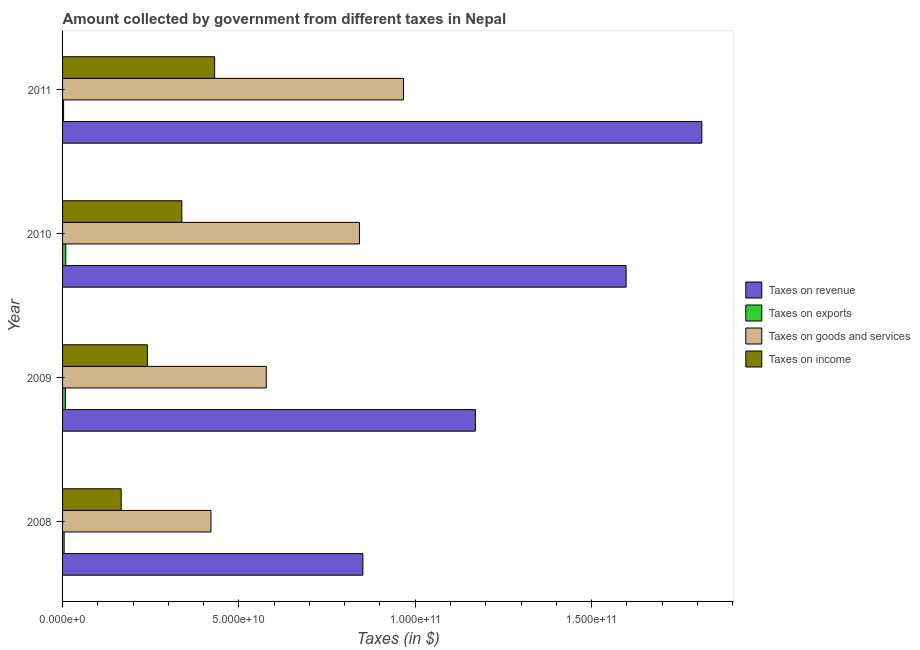How many different coloured bars are there?
Your response must be concise. 4. Are the number of bars on each tick of the Y-axis equal?
Keep it short and to the point. Yes. In how many cases, is the number of bars for a given year not equal to the number of legend labels?
Keep it short and to the point. 0. What is the amount collected as tax on goods in 2008?
Offer a terse response. 4.21e+1. Across all years, what is the maximum amount collected as tax on exports?
Offer a very short reply. 9.15e+08. Across all years, what is the minimum amount collected as tax on goods?
Your response must be concise. 4.21e+1. In which year was the amount collected as tax on revenue minimum?
Ensure brevity in your answer.  2008. What is the total amount collected as tax on revenue in the graph?
Offer a terse response. 5.43e+11. What is the difference between the amount collected as tax on exports in 2010 and that in 2011?
Provide a short and direct response. 6.23e+08. What is the difference between the amount collected as tax on goods in 2009 and the amount collected as tax on exports in 2011?
Make the answer very short. 5.75e+1. What is the average amount collected as tax on goods per year?
Keep it short and to the point. 7.02e+1. In the year 2009, what is the difference between the amount collected as tax on exports and amount collected as tax on income?
Provide a short and direct response. -2.33e+1. Is the amount collected as tax on income in 2008 less than that in 2011?
Your answer should be very brief. Yes. Is the difference between the amount collected as tax on goods in 2009 and 2011 greater than the difference between the amount collected as tax on income in 2009 and 2011?
Ensure brevity in your answer.  No. What is the difference between the highest and the second highest amount collected as tax on income?
Your response must be concise. 9.30e+09. What is the difference between the highest and the lowest amount collected as tax on revenue?
Provide a short and direct response. 9.61e+1. Is it the case that in every year, the sum of the amount collected as tax on goods and amount collected as tax on exports is greater than the sum of amount collected as tax on revenue and amount collected as tax on income?
Your response must be concise. No. What does the 1st bar from the top in 2011 represents?
Make the answer very short. Taxes on income. What does the 3rd bar from the bottom in 2010 represents?
Offer a terse response. Taxes on goods and services. How many bars are there?
Offer a very short reply. 16. How many years are there in the graph?
Make the answer very short. 4. Are the values on the major ticks of X-axis written in scientific E-notation?
Your response must be concise. Yes. Does the graph contain any zero values?
Provide a short and direct response. No. Does the graph contain grids?
Provide a short and direct response. No. How many legend labels are there?
Your answer should be very brief. 4. How are the legend labels stacked?
Provide a short and direct response. Vertical. What is the title of the graph?
Offer a very short reply. Amount collected by government from different taxes in Nepal. Does "Periodicity assessment" appear as one of the legend labels in the graph?
Provide a succinct answer. No. What is the label or title of the X-axis?
Offer a terse response. Taxes (in $). What is the label or title of the Y-axis?
Your answer should be very brief. Year. What is the Taxes (in $) of Taxes on revenue in 2008?
Give a very brief answer. 8.52e+1. What is the Taxes (in $) of Taxes on exports in 2008?
Provide a succinct answer. 4.46e+08. What is the Taxes (in $) of Taxes on goods and services in 2008?
Your response must be concise. 4.21e+1. What is the Taxes (in $) of Taxes on income in 2008?
Ensure brevity in your answer.  1.66e+1. What is the Taxes (in $) in Taxes on revenue in 2009?
Ensure brevity in your answer.  1.17e+11. What is the Taxes (in $) in Taxes on exports in 2009?
Provide a short and direct response. 7.94e+08. What is the Taxes (in $) in Taxes on goods and services in 2009?
Offer a terse response. 5.78e+1. What is the Taxes (in $) in Taxes on income in 2009?
Ensure brevity in your answer.  2.41e+1. What is the Taxes (in $) of Taxes on revenue in 2010?
Offer a terse response. 1.60e+11. What is the Taxes (in $) of Taxes on exports in 2010?
Your answer should be very brief. 9.15e+08. What is the Taxes (in $) in Taxes on goods and services in 2010?
Ensure brevity in your answer.  8.42e+1. What is the Taxes (in $) of Taxes on income in 2010?
Provide a succinct answer. 3.38e+1. What is the Taxes (in $) in Taxes on revenue in 2011?
Make the answer very short. 1.81e+11. What is the Taxes (in $) in Taxes on exports in 2011?
Your response must be concise. 2.92e+08. What is the Taxes (in $) in Taxes on goods and services in 2011?
Provide a succinct answer. 9.67e+1. What is the Taxes (in $) in Taxes on income in 2011?
Your response must be concise. 4.31e+1. Across all years, what is the maximum Taxes (in $) of Taxes on revenue?
Provide a succinct answer. 1.81e+11. Across all years, what is the maximum Taxes (in $) in Taxes on exports?
Your answer should be compact. 9.15e+08. Across all years, what is the maximum Taxes (in $) of Taxes on goods and services?
Give a very brief answer. 9.67e+1. Across all years, what is the maximum Taxes (in $) in Taxes on income?
Ensure brevity in your answer.  4.31e+1. Across all years, what is the minimum Taxes (in $) in Taxes on revenue?
Your answer should be compact. 8.52e+1. Across all years, what is the minimum Taxes (in $) in Taxes on exports?
Give a very brief answer. 2.92e+08. Across all years, what is the minimum Taxes (in $) of Taxes on goods and services?
Your answer should be very brief. 4.21e+1. Across all years, what is the minimum Taxes (in $) in Taxes on income?
Provide a succinct answer. 1.66e+1. What is the total Taxes (in $) in Taxes on revenue in the graph?
Your response must be concise. 5.43e+11. What is the total Taxes (in $) of Taxes on exports in the graph?
Offer a very short reply. 2.45e+09. What is the total Taxes (in $) in Taxes on goods and services in the graph?
Your response must be concise. 2.81e+11. What is the total Taxes (in $) of Taxes on income in the graph?
Make the answer very short. 1.18e+11. What is the difference between the Taxes (in $) of Taxes on revenue in 2008 and that in 2009?
Give a very brief answer. -3.19e+1. What is the difference between the Taxes (in $) of Taxes on exports in 2008 and that in 2009?
Make the answer very short. -3.48e+08. What is the difference between the Taxes (in $) in Taxes on goods and services in 2008 and that in 2009?
Your answer should be compact. -1.57e+1. What is the difference between the Taxes (in $) of Taxes on income in 2008 and that in 2009?
Offer a terse response. -7.42e+09. What is the difference between the Taxes (in $) in Taxes on revenue in 2008 and that in 2010?
Keep it short and to the point. -7.46e+1. What is the difference between the Taxes (in $) in Taxes on exports in 2008 and that in 2010?
Give a very brief answer. -4.70e+08. What is the difference between the Taxes (in $) of Taxes on goods and services in 2008 and that in 2010?
Offer a very short reply. -4.21e+1. What is the difference between the Taxes (in $) in Taxes on income in 2008 and that in 2010?
Make the answer very short. -1.72e+1. What is the difference between the Taxes (in $) in Taxes on revenue in 2008 and that in 2011?
Ensure brevity in your answer.  -9.61e+1. What is the difference between the Taxes (in $) in Taxes on exports in 2008 and that in 2011?
Ensure brevity in your answer.  1.53e+08. What is the difference between the Taxes (in $) of Taxes on goods and services in 2008 and that in 2011?
Give a very brief answer. -5.46e+1. What is the difference between the Taxes (in $) of Taxes on income in 2008 and that in 2011?
Offer a very short reply. -2.65e+1. What is the difference between the Taxes (in $) of Taxes on revenue in 2009 and that in 2010?
Make the answer very short. -4.27e+1. What is the difference between the Taxes (in $) of Taxes on exports in 2009 and that in 2010?
Provide a short and direct response. -1.22e+08. What is the difference between the Taxes (in $) in Taxes on goods and services in 2009 and that in 2010?
Keep it short and to the point. -2.64e+1. What is the difference between the Taxes (in $) of Taxes on income in 2009 and that in 2010?
Offer a very short reply. -9.77e+09. What is the difference between the Taxes (in $) in Taxes on revenue in 2009 and that in 2011?
Keep it short and to the point. -6.42e+1. What is the difference between the Taxes (in $) in Taxes on exports in 2009 and that in 2011?
Give a very brief answer. 5.01e+08. What is the difference between the Taxes (in $) in Taxes on goods and services in 2009 and that in 2011?
Give a very brief answer. -3.89e+1. What is the difference between the Taxes (in $) in Taxes on income in 2009 and that in 2011?
Offer a very short reply. -1.91e+1. What is the difference between the Taxes (in $) in Taxes on revenue in 2010 and that in 2011?
Your answer should be compact. -2.15e+1. What is the difference between the Taxes (in $) in Taxes on exports in 2010 and that in 2011?
Offer a very short reply. 6.23e+08. What is the difference between the Taxes (in $) in Taxes on goods and services in 2010 and that in 2011?
Your answer should be very brief. -1.25e+1. What is the difference between the Taxes (in $) in Taxes on income in 2010 and that in 2011?
Keep it short and to the point. -9.30e+09. What is the difference between the Taxes (in $) of Taxes on revenue in 2008 and the Taxes (in $) of Taxes on exports in 2009?
Offer a very short reply. 8.44e+1. What is the difference between the Taxes (in $) in Taxes on revenue in 2008 and the Taxes (in $) in Taxes on goods and services in 2009?
Keep it short and to the point. 2.74e+1. What is the difference between the Taxes (in $) of Taxes on revenue in 2008 and the Taxes (in $) of Taxes on income in 2009?
Provide a short and direct response. 6.11e+1. What is the difference between the Taxes (in $) in Taxes on exports in 2008 and the Taxes (in $) in Taxes on goods and services in 2009?
Offer a terse response. -5.73e+1. What is the difference between the Taxes (in $) in Taxes on exports in 2008 and the Taxes (in $) in Taxes on income in 2009?
Your answer should be compact. -2.36e+1. What is the difference between the Taxes (in $) of Taxes on goods and services in 2008 and the Taxes (in $) of Taxes on income in 2009?
Provide a succinct answer. 1.80e+1. What is the difference between the Taxes (in $) of Taxes on revenue in 2008 and the Taxes (in $) of Taxes on exports in 2010?
Give a very brief answer. 8.42e+1. What is the difference between the Taxes (in $) of Taxes on revenue in 2008 and the Taxes (in $) of Taxes on goods and services in 2010?
Your response must be concise. 9.85e+08. What is the difference between the Taxes (in $) of Taxes on revenue in 2008 and the Taxes (in $) of Taxes on income in 2010?
Keep it short and to the point. 5.13e+1. What is the difference between the Taxes (in $) of Taxes on exports in 2008 and the Taxes (in $) of Taxes on goods and services in 2010?
Give a very brief answer. -8.37e+1. What is the difference between the Taxes (in $) of Taxes on exports in 2008 and the Taxes (in $) of Taxes on income in 2010?
Make the answer very short. -3.34e+1. What is the difference between the Taxes (in $) of Taxes on goods and services in 2008 and the Taxes (in $) of Taxes on income in 2010?
Make the answer very short. 8.25e+09. What is the difference between the Taxes (in $) of Taxes on revenue in 2008 and the Taxes (in $) of Taxes on exports in 2011?
Your response must be concise. 8.49e+1. What is the difference between the Taxes (in $) of Taxes on revenue in 2008 and the Taxes (in $) of Taxes on goods and services in 2011?
Your response must be concise. -1.15e+1. What is the difference between the Taxes (in $) of Taxes on revenue in 2008 and the Taxes (in $) of Taxes on income in 2011?
Make the answer very short. 4.20e+1. What is the difference between the Taxes (in $) of Taxes on exports in 2008 and the Taxes (in $) of Taxes on goods and services in 2011?
Your response must be concise. -9.62e+1. What is the difference between the Taxes (in $) of Taxes on exports in 2008 and the Taxes (in $) of Taxes on income in 2011?
Provide a short and direct response. -4.27e+1. What is the difference between the Taxes (in $) in Taxes on goods and services in 2008 and the Taxes (in $) in Taxes on income in 2011?
Your answer should be compact. -1.05e+09. What is the difference between the Taxes (in $) in Taxes on revenue in 2009 and the Taxes (in $) in Taxes on exports in 2010?
Ensure brevity in your answer.  1.16e+11. What is the difference between the Taxes (in $) in Taxes on revenue in 2009 and the Taxes (in $) in Taxes on goods and services in 2010?
Offer a very short reply. 3.29e+1. What is the difference between the Taxes (in $) of Taxes on revenue in 2009 and the Taxes (in $) of Taxes on income in 2010?
Give a very brief answer. 8.32e+1. What is the difference between the Taxes (in $) of Taxes on exports in 2009 and the Taxes (in $) of Taxes on goods and services in 2010?
Provide a short and direct response. -8.34e+1. What is the difference between the Taxes (in $) of Taxes on exports in 2009 and the Taxes (in $) of Taxes on income in 2010?
Ensure brevity in your answer.  -3.30e+1. What is the difference between the Taxes (in $) in Taxes on goods and services in 2009 and the Taxes (in $) in Taxes on income in 2010?
Your response must be concise. 2.40e+1. What is the difference between the Taxes (in $) in Taxes on revenue in 2009 and the Taxes (in $) in Taxes on exports in 2011?
Provide a succinct answer. 1.17e+11. What is the difference between the Taxes (in $) in Taxes on revenue in 2009 and the Taxes (in $) in Taxes on goods and services in 2011?
Ensure brevity in your answer.  2.04e+1. What is the difference between the Taxes (in $) of Taxes on revenue in 2009 and the Taxes (in $) of Taxes on income in 2011?
Offer a terse response. 7.39e+1. What is the difference between the Taxes (in $) in Taxes on exports in 2009 and the Taxes (in $) in Taxes on goods and services in 2011?
Provide a short and direct response. -9.59e+1. What is the difference between the Taxes (in $) in Taxes on exports in 2009 and the Taxes (in $) in Taxes on income in 2011?
Provide a short and direct response. -4.23e+1. What is the difference between the Taxes (in $) in Taxes on goods and services in 2009 and the Taxes (in $) in Taxes on income in 2011?
Offer a very short reply. 1.47e+1. What is the difference between the Taxes (in $) of Taxes on revenue in 2010 and the Taxes (in $) of Taxes on exports in 2011?
Your answer should be very brief. 1.59e+11. What is the difference between the Taxes (in $) in Taxes on revenue in 2010 and the Taxes (in $) in Taxes on goods and services in 2011?
Offer a very short reply. 6.31e+1. What is the difference between the Taxes (in $) in Taxes on revenue in 2010 and the Taxes (in $) in Taxes on income in 2011?
Offer a terse response. 1.17e+11. What is the difference between the Taxes (in $) of Taxes on exports in 2010 and the Taxes (in $) of Taxes on goods and services in 2011?
Your answer should be compact. -9.57e+1. What is the difference between the Taxes (in $) in Taxes on exports in 2010 and the Taxes (in $) in Taxes on income in 2011?
Offer a terse response. -4.22e+1. What is the difference between the Taxes (in $) of Taxes on goods and services in 2010 and the Taxes (in $) of Taxes on income in 2011?
Provide a short and direct response. 4.10e+1. What is the average Taxes (in $) of Taxes on revenue per year?
Your answer should be compact. 1.36e+11. What is the average Taxes (in $) of Taxes on exports per year?
Ensure brevity in your answer.  6.12e+08. What is the average Taxes (in $) of Taxes on goods and services per year?
Make the answer very short. 7.02e+1. What is the average Taxes (in $) in Taxes on income per year?
Make the answer very short. 2.94e+1. In the year 2008, what is the difference between the Taxes (in $) in Taxes on revenue and Taxes (in $) in Taxes on exports?
Make the answer very short. 8.47e+1. In the year 2008, what is the difference between the Taxes (in $) of Taxes on revenue and Taxes (in $) of Taxes on goods and services?
Ensure brevity in your answer.  4.31e+1. In the year 2008, what is the difference between the Taxes (in $) of Taxes on revenue and Taxes (in $) of Taxes on income?
Provide a succinct answer. 6.85e+1. In the year 2008, what is the difference between the Taxes (in $) in Taxes on exports and Taxes (in $) in Taxes on goods and services?
Offer a terse response. -4.16e+1. In the year 2008, what is the difference between the Taxes (in $) in Taxes on exports and Taxes (in $) in Taxes on income?
Provide a succinct answer. -1.62e+1. In the year 2008, what is the difference between the Taxes (in $) in Taxes on goods and services and Taxes (in $) in Taxes on income?
Offer a terse response. 2.54e+1. In the year 2009, what is the difference between the Taxes (in $) of Taxes on revenue and Taxes (in $) of Taxes on exports?
Give a very brief answer. 1.16e+11. In the year 2009, what is the difference between the Taxes (in $) in Taxes on revenue and Taxes (in $) in Taxes on goods and services?
Your answer should be compact. 5.93e+1. In the year 2009, what is the difference between the Taxes (in $) in Taxes on revenue and Taxes (in $) in Taxes on income?
Your response must be concise. 9.30e+1. In the year 2009, what is the difference between the Taxes (in $) of Taxes on exports and Taxes (in $) of Taxes on goods and services?
Provide a short and direct response. -5.70e+1. In the year 2009, what is the difference between the Taxes (in $) in Taxes on exports and Taxes (in $) in Taxes on income?
Make the answer very short. -2.33e+1. In the year 2009, what is the difference between the Taxes (in $) in Taxes on goods and services and Taxes (in $) in Taxes on income?
Offer a very short reply. 3.37e+1. In the year 2010, what is the difference between the Taxes (in $) in Taxes on revenue and Taxes (in $) in Taxes on exports?
Ensure brevity in your answer.  1.59e+11. In the year 2010, what is the difference between the Taxes (in $) in Taxes on revenue and Taxes (in $) in Taxes on goods and services?
Offer a terse response. 7.56e+1. In the year 2010, what is the difference between the Taxes (in $) in Taxes on revenue and Taxes (in $) in Taxes on income?
Give a very brief answer. 1.26e+11. In the year 2010, what is the difference between the Taxes (in $) of Taxes on exports and Taxes (in $) of Taxes on goods and services?
Provide a short and direct response. -8.33e+1. In the year 2010, what is the difference between the Taxes (in $) of Taxes on exports and Taxes (in $) of Taxes on income?
Provide a short and direct response. -3.29e+1. In the year 2010, what is the difference between the Taxes (in $) of Taxes on goods and services and Taxes (in $) of Taxes on income?
Ensure brevity in your answer.  5.03e+1. In the year 2011, what is the difference between the Taxes (in $) of Taxes on revenue and Taxes (in $) of Taxes on exports?
Your answer should be very brief. 1.81e+11. In the year 2011, what is the difference between the Taxes (in $) of Taxes on revenue and Taxes (in $) of Taxes on goods and services?
Your response must be concise. 8.46e+1. In the year 2011, what is the difference between the Taxes (in $) of Taxes on revenue and Taxes (in $) of Taxes on income?
Ensure brevity in your answer.  1.38e+11. In the year 2011, what is the difference between the Taxes (in $) of Taxes on exports and Taxes (in $) of Taxes on goods and services?
Provide a short and direct response. -9.64e+1. In the year 2011, what is the difference between the Taxes (in $) of Taxes on exports and Taxes (in $) of Taxes on income?
Make the answer very short. -4.28e+1. In the year 2011, what is the difference between the Taxes (in $) of Taxes on goods and services and Taxes (in $) of Taxes on income?
Your answer should be very brief. 5.35e+1. What is the ratio of the Taxes (in $) in Taxes on revenue in 2008 to that in 2009?
Your answer should be compact. 0.73. What is the ratio of the Taxes (in $) of Taxes on exports in 2008 to that in 2009?
Provide a succinct answer. 0.56. What is the ratio of the Taxes (in $) of Taxes on goods and services in 2008 to that in 2009?
Offer a very short reply. 0.73. What is the ratio of the Taxes (in $) in Taxes on income in 2008 to that in 2009?
Offer a terse response. 0.69. What is the ratio of the Taxes (in $) of Taxes on revenue in 2008 to that in 2010?
Offer a terse response. 0.53. What is the ratio of the Taxes (in $) in Taxes on exports in 2008 to that in 2010?
Keep it short and to the point. 0.49. What is the ratio of the Taxes (in $) in Taxes on goods and services in 2008 to that in 2010?
Your answer should be very brief. 0.5. What is the ratio of the Taxes (in $) of Taxes on income in 2008 to that in 2010?
Ensure brevity in your answer.  0.49. What is the ratio of the Taxes (in $) in Taxes on revenue in 2008 to that in 2011?
Your answer should be very brief. 0.47. What is the ratio of the Taxes (in $) in Taxes on exports in 2008 to that in 2011?
Your response must be concise. 1.52. What is the ratio of the Taxes (in $) in Taxes on goods and services in 2008 to that in 2011?
Ensure brevity in your answer.  0.44. What is the ratio of the Taxes (in $) of Taxes on income in 2008 to that in 2011?
Ensure brevity in your answer.  0.39. What is the ratio of the Taxes (in $) in Taxes on revenue in 2009 to that in 2010?
Ensure brevity in your answer.  0.73. What is the ratio of the Taxes (in $) in Taxes on exports in 2009 to that in 2010?
Ensure brevity in your answer.  0.87. What is the ratio of the Taxes (in $) of Taxes on goods and services in 2009 to that in 2010?
Ensure brevity in your answer.  0.69. What is the ratio of the Taxes (in $) of Taxes on income in 2009 to that in 2010?
Offer a terse response. 0.71. What is the ratio of the Taxes (in $) in Taxes on revenue in 2009 to that in 2011?
Offer a terse response. 0.65. What is the ratio of the Taxes (in $) of Taxes on exports in 2009 to that in 2011?
Ensure brevity in your answer.  2.71. What is the ratio of the Taxes (in $) of Taxes on goods and services in 2009 to that in 2011?
Keep it short and to the point. 0.6. What is the ratio of the Taxes (in $) of Taxes on income in 2009 to that in 2011?
Give a very brief answer. 0.56. What is the ratio of the Taxes (in $) of Taxes on revenue in 2010 to that in 2011?
Ensure brevity in your answer.  0.88. What is the ratio of the Taxes (in $) of Taxes on exports in 2010 to that in 2011?
Your answer should be very brief. 3.13. What is the ratio of the Taxes (in $) of Taxes on goods and services in 2010 to that in 2011?
Offer a terse response. 0.87. What is the ratio of the Taxes (in $) in Taxes on income in 2010 to that in 2011?
Keep it short and to the point. 0.78. What is the difference between the highest and the second highest Taxes (in $) of Taxes on revenue?
Your answer should be compact. 2.15e+1. What is the difference between the highest and the second highest Taxes (in $) of Taxes on exports?
Give a very brief answer. 1.22e+08. What is the difference between the highest and the second highest Taxes (in $) in Taxes on goods and services?
Give a very brief answer. 1.25e+1. What is the difference between the highest and the second highest Taxes (in $) of Taxes on income?
Your response must be concise. 9.30e+09. What is the difference between the highest and the lowest Taxes (in $) of Taxes on revenue?
Offer a very short reply. 9.61e+1. What is the difference between the highest and the lowest Taxes (in $) of Taxes on exports?
Offer a very short reply. 6.23e+08. What is the difference between the highest and the lowest Taxes (in $) of Taxes on goods and services?
Your answer should be very brief. 5.46e+1. What is the difference between the highest and the lowest Taxes (in $) of Taxes on income?
Offer a very short reply. 2.65e+1. 